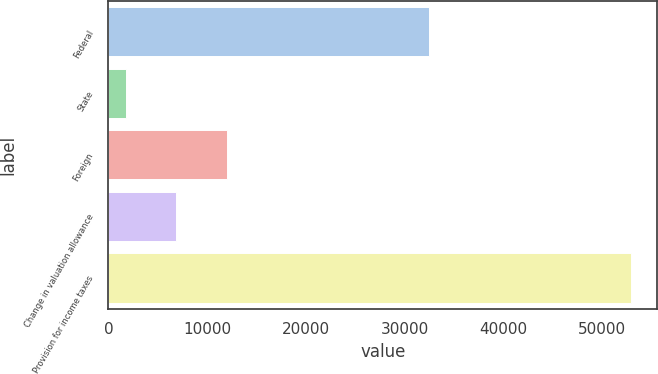<chart> <loc_0><loc_0><loc_500><loc_500><bar_chart><fcel>Federal<fcel>State<fcel>Foreign<fcel>Change in valuation allowance<fcel>Provision for income taxes<nl><fcel>32414<fcel>1741<fcel>11972.4<fcel>6856.7<fcel>52898<nl></chart> 